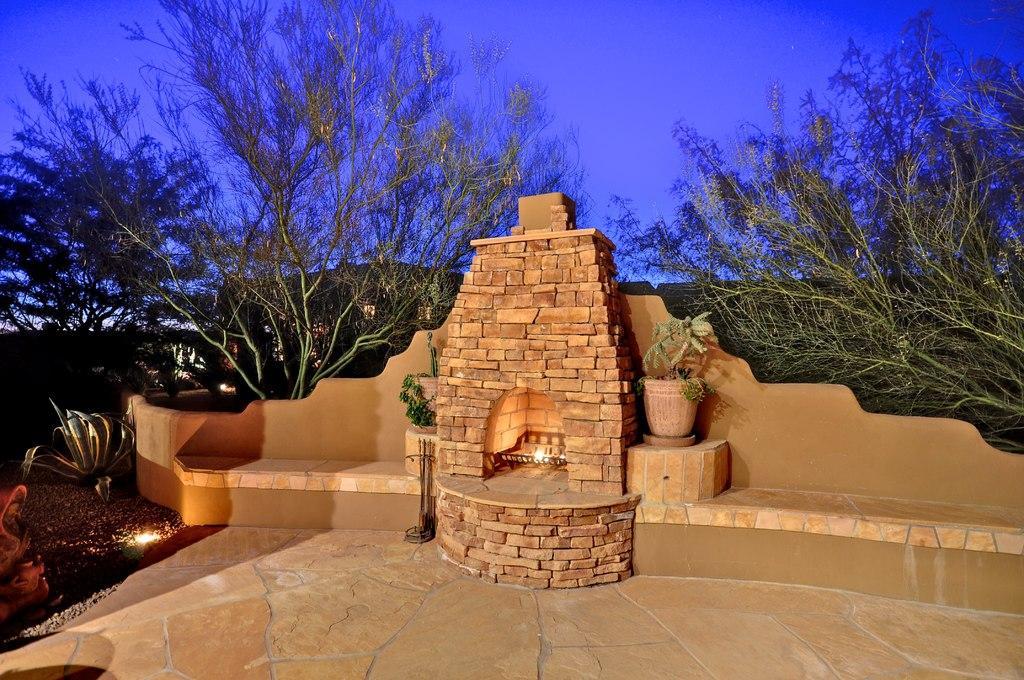Please provide a concise description of this image. In the image there is a floor, behind the floor there is some brick work and there is a light inside the arch of the bricks, on the either side of the bricks there are plants, in the background there are trees. 